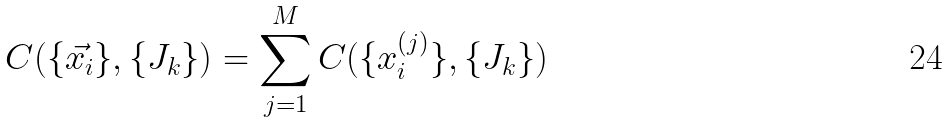<formula> <loc_0><loc_0><loc_500><loc_500>C ( \{ \vec { x _ { i } } \} , \{ J _ { k } \} ) = \sum _ { j = 1 } ^ { M } C ( \{ x _ { i } ^ { ( j ) } \} , \{ J _ { k } \} )</formula> 